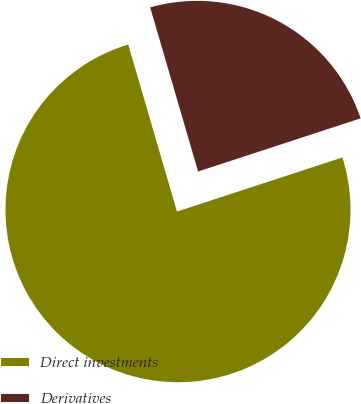Convert chart. <chart><loc_0><loc_0><loc_500><loc_500><pie_chart><fcel>Direct investments<fcel>Derivatives<nl><fcel>75.51%<fcel>24.49%<nl></chart> 